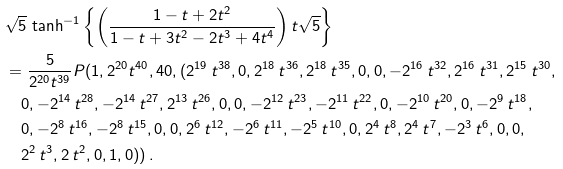<formula> <loc_0><loc_0><loc_500><loc_500>& \sqrt { 5 } \, \tanh ^ { - 1 } \left \{ \left ( \frac { 1 - t + 2 t ^ { 2 } } { 1 - t + 3 t ^ { 2 } - 2 t ^ { 3 } + 4 t ^ { 4 } } \right ) t \sqrt { 5 } \right \} \\ & = \frac { 5 } { 2 ^ { 2 0 } t ^ { 3 9 } } P ( 1 , 2 ^ { 2 0 } t ^ { 4 0 } , 4 0 , ( 2 ^ { 1 9 } \, t ^ { 3 8 } , 0 , 2 ^ { 1 8 } \, t ^ { 3 6 } , 2 ^ { 1 8 } \, t ^ { 3 5 } , 0 , 0 , - 2 ^ { 1 6 } \, t ^ { 3 2 } , 2 ^ { 1 6 } \, t ^ { 3 1 } , 2 ^ { 1 5 } \, t ^ { 3 0 } , \\ & \quad 0 , - 2 ^ { 1 4 } \, t ^ { 2 8 } , - 2 ^ { 1 4 } \, t ^ { 2 7 } , 2 ^ { 1 3 } \, t ^ { 2 6 } , 0 , 0 , - 2 ^ { 1 2 } \, t ^ { 2 3 } , - 2 ^ { 1 1 } \, t ^ { 2 2 } , 0 , - 2 ^ { 1 0 } \, t ^ { 2 0 } , 0 , - 2 ^ { 9 } \, t ^ { 1 8 } , \\ & \quad 0 , - 2 ^ { 8 } \, t ^ { 1 6 } , - 2 ^ { 8 } \, t ^ { 1 5 } , 0 , 0 , 2 ^ { 6 } \, t ^ { 1 2 } , - 2 ^ { 6 } \, t ^ { 1 1 } , - 2 ^ { 5 } \, t ^ { 1 0 } , 0 , 2 ^ { 4 } \, t ^ { 8 } , 2 ^ { 4 } \, t ^ { 7 } , - 2 ^ { 3 } \, t ^ { 6 } , 0 , 0 , \\ & \quad 2 ^ { 2 } \, t ^ { 3 } , 2 \, t ^ { 2 } , 0 , 1 , 0 ) ) \, .</formula> 